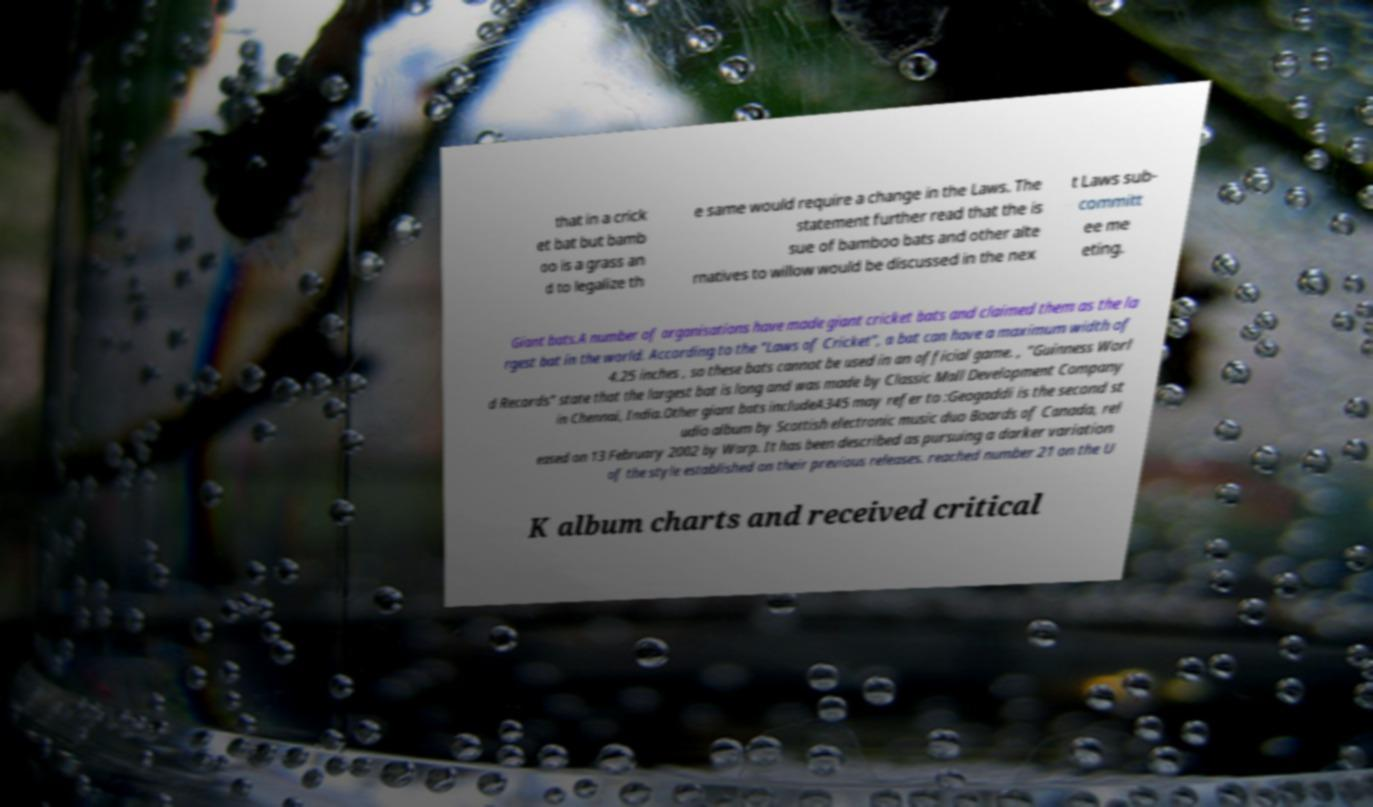Could you assist in decoding the text presented in this image and type it out clearly? that in a crick et bat but bamb oo is a grass an d to legalize th e same would require a change in the Laws. The statement further read that the is sue of bamboo bats and other alte rnatives to willow would be discussed in the nex t Laws sub- committ ee me eting. Giant bats.A number of organisations have made giant cricket bats and claimed them as the la rgest bat in the world. According to the "Laws of Cricket", a bat can have a maximum width of 4.25 inches , so these bats cannot be used in an official game. , "Guinness Worl d Records" state that the largest bat is long and was made by Classic Mall Development Company in Chennai, India.Other giant bats includeA345 may refer to :Geogaddi is the second st udio album by Scottish electronic music duo Boards of Canada, rel eased on 13 February 2002 by Warp. It has been described as pursuing a darker variation of the style established on their previous releases. reached number 21 on the U K album charts and received critical 